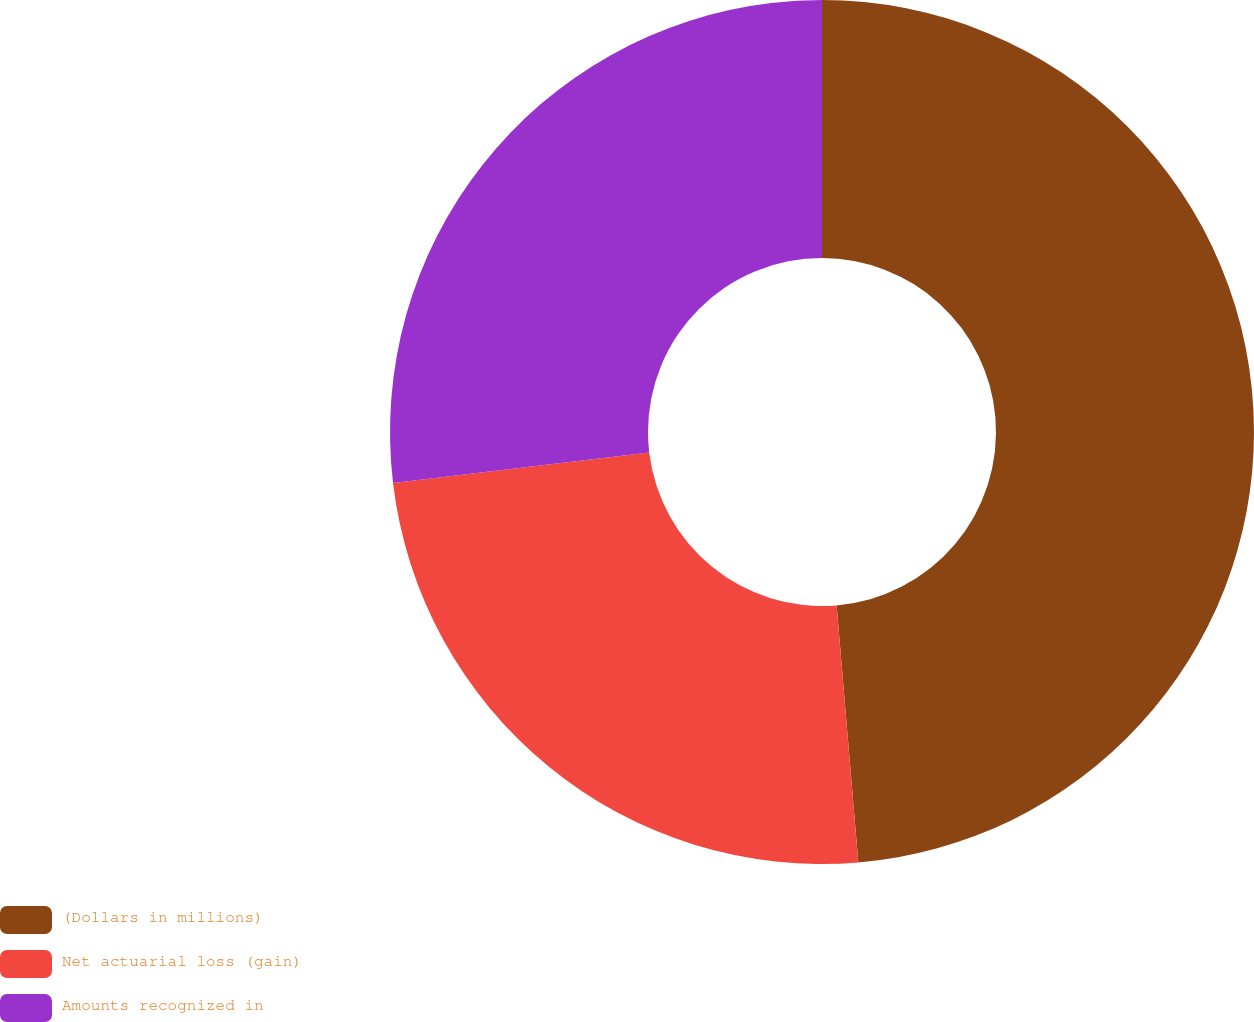Convert chart. <chart><loc_0><loc_0><loc_500><loc_500><pie_chart><fcel>(Dollars in millions)<fcel>Net actuarial loss (gain)<fcel>Amounts recognized in<nl><fcel>48.66%<fcel>24.46%<fcel>26.88%<nl></chart> 